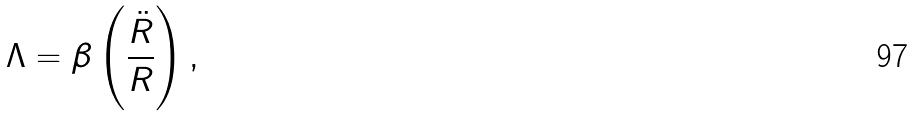Convert formula to latex. <formula><loc_0><loc_0><loc_500><loc_500>\Lambda = \beta \left ( \frac { \ddot { R } } { R } \right ) ,</formula> 